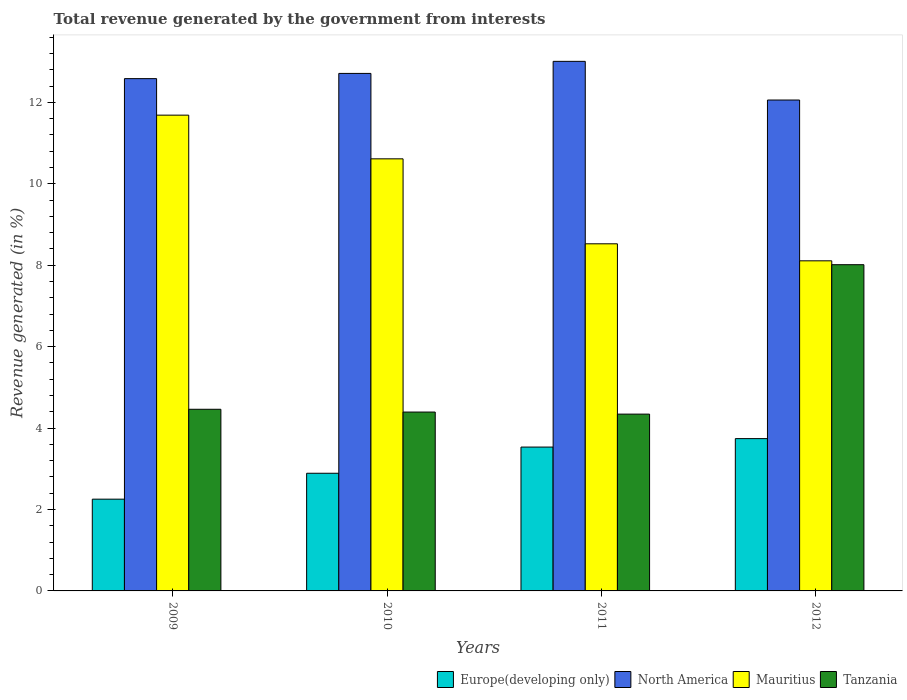Are the number of bars per tick equal to the number of legend labels?
Give a very brief answer. Yes. Are the number of bars on each tick of the X-axis equal?
Make the answer very short. Yes. How many bars are there on the 3rd tick from the right?
Offer a very short reply. 4. What is the label of the 4th group of bars from the left?
Ensure brevity in your answer.  2012. In how many cases, is the number of bars for a given year not equal to the number of legend labels?
Make the answer very short. 0. What is the total revenue generated in Europe(developing only) in 2010?
Give a very brief answer. 2.89. Across all years, what is the maximum total revenue generated in North America?
Ensure brevity in your answer.  13.01. Across all years, what is the minimum total revenue generated in Europe(developing only)?
Give a very brief answer. 2.25. In which year was the total revenue generated in Europe(developing only) minimum?
Ensure brevity in your answer.  2009. What is the total total revenue generated in Europe(developing only) in the graph?
Offer a very short reply. 12.42. What is the difference between the total revenue generated in Europe(developing only) in 2009 and that in 2010?
Offer a terse response. -0.64. What is the difference between the total revenue generated in Mauritius in 2010 and the total revenue generated in North America in 2009?
Your response must be concise. -1.97. What is the average total revenue generated in Mauritius per year?
Offer a very short reply. 9.73. In the year 2011, what is the difference between the total revenue generated in Mauritius and total revenue generated in North America?
Provide a succinct answer. -4.48. What is the ratio of the total revenue generated in Mauritius in 2009 to that in 2012?
Provide a succinct answer. 1.44. Is the total revenue generated in Mauritius in 2009 less than that in 2012?
Keep it short and to the point. No. What is the difference between the highest and the second highest total revenue generated in Mauritius?
Ensure brevity in your answer.  1.07. What is the difference between the highest and the lowest total revenue generated in Europe(developing only)?
Your answer should be compact. 1.49. Is it the case that in every year, the sum of the total revenue generated in Tanzania and total revenue generated in North America is greater than the sum of total revenue generated in Mauritius and total revenue generated in Europe(developing only)?
Ensure brevity in your answer.  No. What does the 4th bar from the right in 2011 represents?
Your answer should be compact. Europe(developing only). Is it the case that in every year, the sum of the total revenue generated in North America and total revenue generated in Tanzania is greater than the total revenue generated in Europe(developing only)?
Offer a terse response. Yes. How many bars are there?
Offer a terse response. 16. How many years are there in the graph?
Make the answer very short. 4. What is the difference between two consecutive major ticks on the Y-axis?
Offer a terse response. 2. Are the values on the major ticks of Y-axis written in scientific E-notation?
Your answer should be very brief. No. Does the graph contain grids?
Your answer should be very brief. No. Where does the legend appear in the graph?
Make the answer very short. Bottom right. What is the title of the graph?
Provide a short and direct response. Total revenue generated by the government from interests. Does "Moldova" appear as one of the legend labels in the graph?
Offer a very short reply. No. What is the label or title of the Y-axis?
Provide a succinct answer. Revenue generated (in %). What is the Revenue generated (in %) in Europe(developing only) in 2009?
Provide a short and direct response. 2.25. What is the Revenue generated (in %) in North America in 2009?
Provide a short and direct response. 12.58. What is the Revenue generated (in %) in Mauritius in 2009?
Ensure brevity in your answer.  11.68. What is the Revenue generated (in %) in Tanzania in 2009?
Your answer should be compact. 4.46. What is the Revenue generated (in %) of Europe(developing only) in 2010?
Offer a very short reply. 2.89. What is the Revenue generated (in %) in North America in 2010?
Make the answer very short. 12.71. What is the Revenue generated (in %) in Mauritius in 2010?
Your response must be concise. 10.61. What is the Revenue generated (in %) of Tanzania in 2010?
Offer a very short reply. 4.39. What is the Revenue generated (in %) of Europe(developing only) in 2011?
Provide a short and direct response. 3.53. What is the Revenue generated (in %) of North America in 2011?
Provide a succinct answer. 13.01. What is the Revenue generated (in %) in Mauritius in 2011?
Provide a short and direct response. 8.53. What is the Revenue generated (in %) of Tanzania in 2011?
Your answer should be compact. 4.34. What is the Revenue generated (in %) of Europe(developing only) in 2012?
Offer a terse response. 3.74. What is the Revenue generated (in %) of North America in 2012?
Ensure brevity in your answer.  12.06. What is the Revenue generated (in %) in Mauritius in 2012?
Offer a terse response. 8.11. What is the Revenue generated (in %) of Tanzania in 2012?
Provide a short and direct response. 8.01. Across all years, what is the maximum Revenue generated (in %) in Europe(developing only)?
Offer a terse response. 3.74. Across all years, what is the maximum Revenue generated (in %) of North America?
Your answer should be very brief. 13.01. Across all years, what is the maximum Revenue generated (in %) of Mauritius?
Provide a short and direct response. 11.68. Across all years, what is the maximum Revenue generated (in %) in Tanzania?
Your answer should be compact. 8.01. Across all years, what is the minimum Revenue generated (in %) of Europe(developing only)?
Provide a succinct answer. 2.25. Across all years, what is the minimum Revenue generated (in %) of North America?
Your response must be concise. 12.06. Across all years, what is the minimum Revenue generated (in %) of Mauritius?
Provide a short and direct response. 8.11. Across all years, what is the minimum Revenue generated (in %) in Tanzania?
Offer a very short reply. 4.34. What is the total Revenue generated (in %) of Europe(developing only) in the graph?
Your response must be concise. 12.42. What is the total Revenue generated (in %) in North America in the graph?
Your response must be concise. 50.35. What is the total Revenue generated (in %) of Mauritius in the graph?
Ensure brevity in your answer.  38.93. What is the total Revenue generated (in %) in Tanzania in the graph?
Keep it short and to the point. 21.21. What is the difference between the Revenue generated (in %) of Europe(developing only) in 2009 and that in 2010?
Offer a very short reply. -0.64. What is the difference between the Revenue generated (in %) in North America in 2009 and that in 2010?
Give a very brief answer. -0.13. What is the difference between the Revenue generated (in %) of Mauritius in 2009 and that in 2010?
Provide a succinct answer. 1.07. What is the difference between the Revenue generated (in %) in Tanzania in 2009 and that in 2010?
Your answer should be compact. 0.07. What is the difference between the Revenue generated (in %) in Europe(developing only) in 2009 and that in 2011?
Offer a terse response. -1.28. What is the difference between the Revenue generated (in %) in North America in 2009 and that in 2011?
Offer a very short reply. -0.42. What is the difference between the Revenue generated (in %) of Mauritius in 2009 and that in 2011?
Offer a terse response. 3.16. What is the difference between the Revenue generated (in %) of Tanzania in 2009 and that in 2011?
Keep it short and to the point. 0.12. What is the difference between the Revenue generated (in %) in Europe(developing only) in 2009 and that in 2012?
Provide a short and direct response. -1.49. What is the difference between the Revenue generated (in %) of North America in 2009 and that in 2012?
Ensure brevity in your answer.  0.53. What is the difference between the Revenue generated (in %) of Mauritius in 2009 and that in 2012?
Your response must be concise. 3.58. What is the difference between the Revenue generated (in %) of Tanzania in 2009 and that in 2012?
Your answer should be very brief. -3.55. What is the difference between the Revenue generated (in %) in Europe(developing only) in 2010 and that in 2011?
Keep it short and to the point. -0.64. What is the difference between the Revenue generated (in %) in North America in 2010 and that in 2011?
Give a very brief answer. -0.3. What is the difference between the Revenue generated (in %) in Mauritius in 2010 and that in 2011?
Make the answer very short. 2.09. What is the difference between the Revenue generated (in %) of Tanzania in 2010 and that in 2011?
Ensure brevity in your answer.  0.05. What is the difference between the Revenue generated (in %) of Europe(developing only) in 2010 and that in 2012?
Ensure brevity in your answer.  -0.85. What is the difference between the Revenue generated (in %) of North America in 2010 and that in 2012?
Offer a very short reply. 0.65. What is the difference between the Revenue generated (in %) of Mauritius in 2010 and that in 2012?
Your answer should be compact. 2.5. What is the difference between the Revenue generated (in %) of Tanzania in 2010 and that in 2012?
Your response must be concise. -3.62. What is the difference between the Revenue generated (in %) in Europe(developing only) in 2011 and that in 2012?
Provide a short and direct response. -0.21. What is the difference between the Revenue generated (in %) of North America in 2011 and that in 2012?
Offer a terse response. 0.95. What is the difference between the Revenue generated (in %) in Mauritius in 2011 and that in 2012?
Give a very brief answer. 0.42. What is the difference between the Revenue generated (in %) in Tanzania in 2011 and that in 2012?
Keep it short and to the point. -3.67. What is the difference between the Revenue generated (in %) in Europe(developing only) in 2009 and the Revenue generated (in %) in North America in 2010?
Make the answer very short. -10.46. What is the difference between the Revenue generated (in %) in Europe(developing only) in 2009 and the Revenue generated (in %) in Mauritius in 2010?
Your answer should be very brief. -8.36. What is the difference between the Revenue generated (in %) in Europe(developing only) in 2009 and the Revenue generated (in %) in Tanzania in 2010?
Offer a terse response. -2.14. What is the difference between the Revenue generated (in %) of North America in 2009 and the Revenue generated (in %) of Mauritius in 2010?
Ensure brevity in your answer.  1.97. What is the difference between the Revenue generated (in %) of North America in 2009 and the Revenue generated (in %) of Tanzania in 2010?
Your answer should be very brief. 8.19. What is the difference between the Revenue generated (in %) in Mauritius in 2009 and the Revenue generated (in %) in Tanzania in 2010?
Give a very brief answer. 7.29. What is the difference between the Revenue generated (in %) of Europe(developing only) in 2009 and the Revenue generated (in %) of North America in 2011?
Provide a succinct answer. -10.75. What is the difference between the Revenue generated (in %) in Europe(developing only) in 2009 and the Revenue generated (in %) in Mauritius in 2011?
Offer a terse response. -6.27. What is the difference between the Revenue generated (in %) in Europe(developing only) in 2009 and the Revenue generated (in %) in Tanzania in 2011?
Ensure brevity in your answer.  -2.09. What is the difference between the Revenue generated (in %) of North America in 2009 and the Revenue generated (in %) of Mauritius in 2011?
Your answer should be very brief. 4.06. What is the difference between the Revenue generated (in %) of North America in 2009 and the Revenue generated (in %) of Tanzania in 2011?
Give a very brief answer. 8.24. What is the difference between the Revenue generated (in %) in Mauritius in 2009 and the Revenue generated (in %) in Tanzania in 2011?
Offer a very short reply. 7.34. What is the difference between the Revenue generated (in %) in Europe(developing only) in 2009 and the Revenue generated (in %) in North America in 2012?
Your answer should be compact. -9.8. What is the difference between the Revenue generated (in %) of Europe(developing only) in 2009 and the Revenue generated (in %) of Mauritius in 2012?
Ensure brevity in your answer.  -5.85. What is the difference between the Revenue generated (in %) in Europe(developing only) in 2009 and the Revenue generated (in %) in Tanzania in 2012?
Your answer should be very brief. -5.76. What is the difference between the Revenue generated (in %) in North America in 2009 and the Revenue generated (in %) in Mauritius in 2012?
Your answer should be compact. 4.47. What is the difference between the Revenue generated (in %) in North America in 2009 and the Revenue generated (in %) in Tanzania in 2012?
Ensure brevity in your answer.  4.57. What is the difference between the Revenue generated (in %) in Mauritius in 2009 and the Revenue generated (in %) in Tanzania in 2012?
Keep it short and to the point. 3.67. What is the difference between the Revenue generated (in %) in Europe(developing only) in 2010 and the Revenue generated (in %) in North America in 2011?
Your response must be concise. -10.12. What is the difference between the Revenue generated (in %) in Europe(developing only) in 2010 and the Revenue generated (in %) in Mauritius in 2011?
Ensure brevity in your answer.  -5.64. What is the difference between the Revenue generated (in %) of Europe(developing only) in 2010 and the Revenue generated (in %) of Tanzania in 2011?
Give a very brief answer. -1.45. What is the difference between the Revenue generated (in %) in North America in 2010 and the Revenue generated (in %) in Mauritius in 2011?
Your answer should be compact. 4.18. What is the difference between the Revenue generated (in %) of North America in 2010 and the Revenue generated (in %) of Tanzania in 2011?
Make the answer very short. 8.37. What is the difference between the Revenue generated (in %) of Mauritius in 2010 and the Revenue generated (in %) of Tanzania in 2011?
Offer a very short reply. 6.27. What is the difference between the Revenue generated (in %) in Europe(developing only) in 2010 and the Revenue generated (in %) in North America in 2012?
Provide a succinct answer. -9.17. What is the difference between the Revenue generated (in %) of Europe(developing only) in 2010 and the Revenue generated (in %) of Mauritius in 2012?
Ensure brevity in your answer.  -5.22. What is the difference between the Revenue generated (in %) of Europe(developing only) in 2010 and the Revenue generated (in %) of Tanzania in 2012?
Make the answer very short. -5.12. What is the difference between the Revenue generated (in %) of North America in 2010 and the Revenue generated (in %) of Mauritius in 2012?
Ensure brevity in your answer.  4.6. What is the difference between the Revenue generated (in %) in North America in 2010 and the Revenue generated (in %) in Tanzania in 2012?
Offer a terse response. 4.7. What is the difference between the Revenue generated (in %) in Mauritius in 2010 and the Revenue generated (in %) in Tanzania in 2012?
Your answer should be very brief. 2.6. What is the difference between the Revenue generated (in %) in Europe(developing only) in 2011 and the Revenue generated (in %) in North America in 2012?
Provide a short and direct response. -8.52. What is the difference between the Revenue generated (in %) of Europe(developing only) in 2011 and the Revenue generated (in %) of Mauritius in 2012?
Your response must be concise. -4.57. What is the difference between the Revenue generated (in %) in Europe(developing only) in 2011 and the Revenue generated (in %) in Tanzania in 2012?
Provide a succinct answer. -4.48. What is the difference between the Revenue generated (in %) of North America in 2011 and the Revenue generated (in %) of Mauritius in 2012?
Your answer should be very brief. 4.9. What is the difference between the Revenue generated (in %) of North America in 2011 and the Revenue generated (in %) of Tanzania in 2012?
Offer a terse response. 4.99. What is the difference between the Revenue generated (in %) in Mauritius in 2011 and the Revenue generated (in %) in Tanzania in 2012?
Keep it short and to the point. 0.51. What is the average Revenue generated (in %) of Europe(developing only) per year?
Keep it short and to the point. 3.1. What is the average Revenue generated (in %) in North America per year?
Offer a very short reply. 12.59. What is the average Revenue generated (in %) in Mauritius per year?
Your response must be concise. 9.73. What is the average Revenue generated (in %) in Tanzania per year?
Make the answer very short. 5.3. In the year 2009, what is the difference between the Revenue generated (in %) of Europe(developing only) and Revenue generated (in %) of North America?
Make the answer very short. -10.33. In the year 2009, what is the difference between the Revenue generated (in %) of Europe(developing only) and Revenue generated (in %) of Mauritius?
Ensure brevity in your answer.  -9.43. In the year 2009, what is the difference between the Revenue generated (in %) in Europe(developing only) and Revenue generated (in %) in Tanzania?
Your response must be concise. -2.21. In the year 2009, what is the difference between the Revenue generated (in %) in North America and Revenue generated (in %) in Mauritius?
Offer a terse response. 0.9. In the year 2009, what is the difference between the Revenue generated (in %) in North America and Revenue generated (in %) in Tanzania?
Provide a short and direct response. 8.12. In the year 2009, what is the difference between the Revenue generated (in %) of Mauritius and Revenue generated (in %) of Tanzania?
Provide a succinct answer. 7.22. In the year 2010, what is the difference between the Revenue generated (in %) in Europe(developing only) and Revenue generated (in %) in North America?
Make the answer very short. -9.82. In the year 2010, what is the difference between the Revenue generated (in %) of Europe(developing only) and Revenue generated (in %) of Mauritius?
Make the answer very short. -7.72. In the year 2010, what is the difference between the Revenue generated (in %) of Europe(developing only) and Revenue generated (in %) of Tanzania?
Make the answer very short. -1.5. In the year 2010, what is the difference between the Revenue generated (in %) of North America and Revenue generated (in %) of Mauritius?
Your answer should be compact. 2.1. In the year 2010, what is the difference between the Revenue generated (in %) in North America and Revenue generated (in %) in Tanzania?
Provide a short and direct response. 8.32. In the year 2010, what is the difference between the Revenue generated (in %) of Mauritius and Revenue generated (in %) of Tanzania?
Ensure brevity in your answer.  6.22. In the year 2011, what is the difference between the Revenue generated (in %) in Europe(developing only) and Revenue generated (in %) in North America?
Your answer should be very brief. -9.47. In the year 2011, what is the difference between the Revenue generated (in %) of Europe(developing only) and Revenue generated (in %) of Mauritius?
Offer a terse response. -4.99. In the year 2011, what is the difference between the Revenue generated (in %) in Europe(developing only) and Revenue generated (in %) in Tanzania?
Provide a short and direct response. -0.81. In the year 2011, what is the difference between the Revenue generated (in %) of North America and Revenue generated (in %) of Mauritius?
Offer a very short reply. 4.48. In the year 2011, what is the difference between the Revenue generated (in %) of North America and Revenue generated (in %) of Tanzania?
Give a very brief answer. 8.66. In the year 2011, what is the difference between the Revenue generated (in %) in Mauritius and Revenue generated (in %) in Tanzania?
Your response must be concise. 4.18. In the year 2012, what is the difference between the Revenue generated (in %) in Europe(developing only) and Revenue generated (in %) in North America?
Offer a very short reply. -8.32. In the year 2012, what is the difference between the Revenue generated (in %) of Europe(developing only) and Revenue generated (in %) of Mauritius?
Ensure brevity in your answer.  -4.37. In the year 2012, what is the difference between the Revenue generated (in %) in Europe(developing only) and Revenue generated (in %) in Tanzania?
Provide a succinct answer. -4.27. In the year 2012, what is the difference between the Revenue generated (in %) in North America and Revenue generated (in %) in Mauritius?
Offer a terse response. 3.95. In the year 2012, what is the difference between the Revenue generated (in %) of North America and Revenue generated (in %) of Tanzania?
Offer a very short reply. 4.04. In the year 2012, what is the difference between the Revenue generated (in %) in Mauritius and Revenue generated (in %) in Tanzania?
Make the answer very short. 0.1. What is the ratio of the Revenue generated (in %) of Europe(developing only) in 2009 to that in 2010?
Provide a succinct answer. 0.78. What is the ratio of the Revenue generated (in %) of North America in 2009 to that in 2010?
Your answer should be very brief. 0.99. What is the ratio of the Revenue generated (in %) in Mauritius in 2009 to that in 2010?
Make the answer very short. 1.1. What is the ratio of the Revenue generated (in %) of Tanzania in 2009 to that in 2010?
Give a very brief answer. 1.02. What is the ratio of the Revenue generated (in %) in Europe(developing only) in 2009 to that in 2011?
Your response must be concise. 0.64. What is the ratio of the Revenue generated (in %) of North America in 2009 to that in 2011?
Provide a short and direct response. 0.97. What is the ratio of the Revenue generated (in %) of Mauritius in 2009 to that in 2011?
Offer a very short reply. 1.37. What is the ratio of the Revenue generated (in %) in Tanzania in 2009 to that in 2011?
Keep it short and to the point. 1.03. What is the ratio of the Revenue generated (in %) in Europe(developing only) in 2009 to that in 2012?
Offer a terse response. 0.6. What is the ratio of the Revenue generated (in %) of North America in 2009 to that in 2012?
Provide a short and direct response. 1.04. What is the ratio of the Revenue generated (in %) in Mauritius in 2009 to that in 2012?
Your response must be concise. 1.44. What is the ratio of the Revenue generated (in %) in Tanzania in 2009 to that in 2012?
Provide a short and direct response. 0.56. What is the ratio of the Revenue generated (in %) of Europe(developing only) in 2010 to that in 2011?
Ensure brevity in your answer.  0.82. What is the ratio of the Revenue generated (in %) in North America in 2010 to that in 2011?
Your response must be concise. 0.98. What is the ratio of the Revenue generated (in %) in Mauritius in 2010 to that in 2011?
Your answer should be very brief. 1.24. What is the ratio of the Revenue generated (in %) of Tanzania in 2010 to that in 2011?
Provide a short and direct response. 1.01. What is the ratio of the Revenue generated (in %) in Europe(developing only) in 2010 to that in 2012?
Provide a short and direct response. 0.77. What is the ratio of the Revenue generated (in %) of North America in 2010 to that in 2012?
Offer a very short reply. 1.05. What is the ratio of the Revenue generated (in %) of Mauritius in 2010 to that in 2012?
Offer a very short reply. 1.31. What is the ratio of the Revenue generated (in %) in Tanzania in 2010 to that in 2012?
Offer a terse response. 0.55. What is the ratio of the Revenue generated (in %) in Europe(developing only) in 2011 to that in 2012?
Provide a succinct answer. 0.94. What is the ratio of the Revenue generated (in %) of North America in 2011 to that in 2012?
Your answer should be compact. 1.08. What is the ratio of the Revenue generated (in %) of Mauritius in 2011 to that in 2012?
Your answer should be very brief. 1.05. What is the ratio of the Revenue generated (in %) in Tanzania in 2011 to that in 2012?
Keep it short and to the point. 0.54. What is the difference between the highest and the second highest Revenue generated (in %) in Europe(developing only)?
Offer a very short reply. 0.21. What is the difference between the highest and the second highest Revenue generated (in %) of North America?
Ensure brevity in your answer.  0.3. What is the difference between the highest and the second highest Revenue generated (in %) in Mauritius?
Ensure brevity in your answer.  1.07. What is the difference between the highest and the second highest Revenue generated (in %) of Tanzania?
Provide a short and direct response. 3.55. What is the difference between the highest and the lowest Revenue generated (in %) in Europe(developing only)?
Your answer should be compact. 1.49. What is the difference between the highest and the lowest Revenue generated (in %) of North America?
Make the answer very short. 0.95. What is the difference between the highest and the lowest Revenue generated (in %) of Mauritius?
Make the answer very short. 3.58. What is the difference between the highest and the lowest Revenue generated (in %) of Tanzania?
Provide a short and direct response. 3.67. 